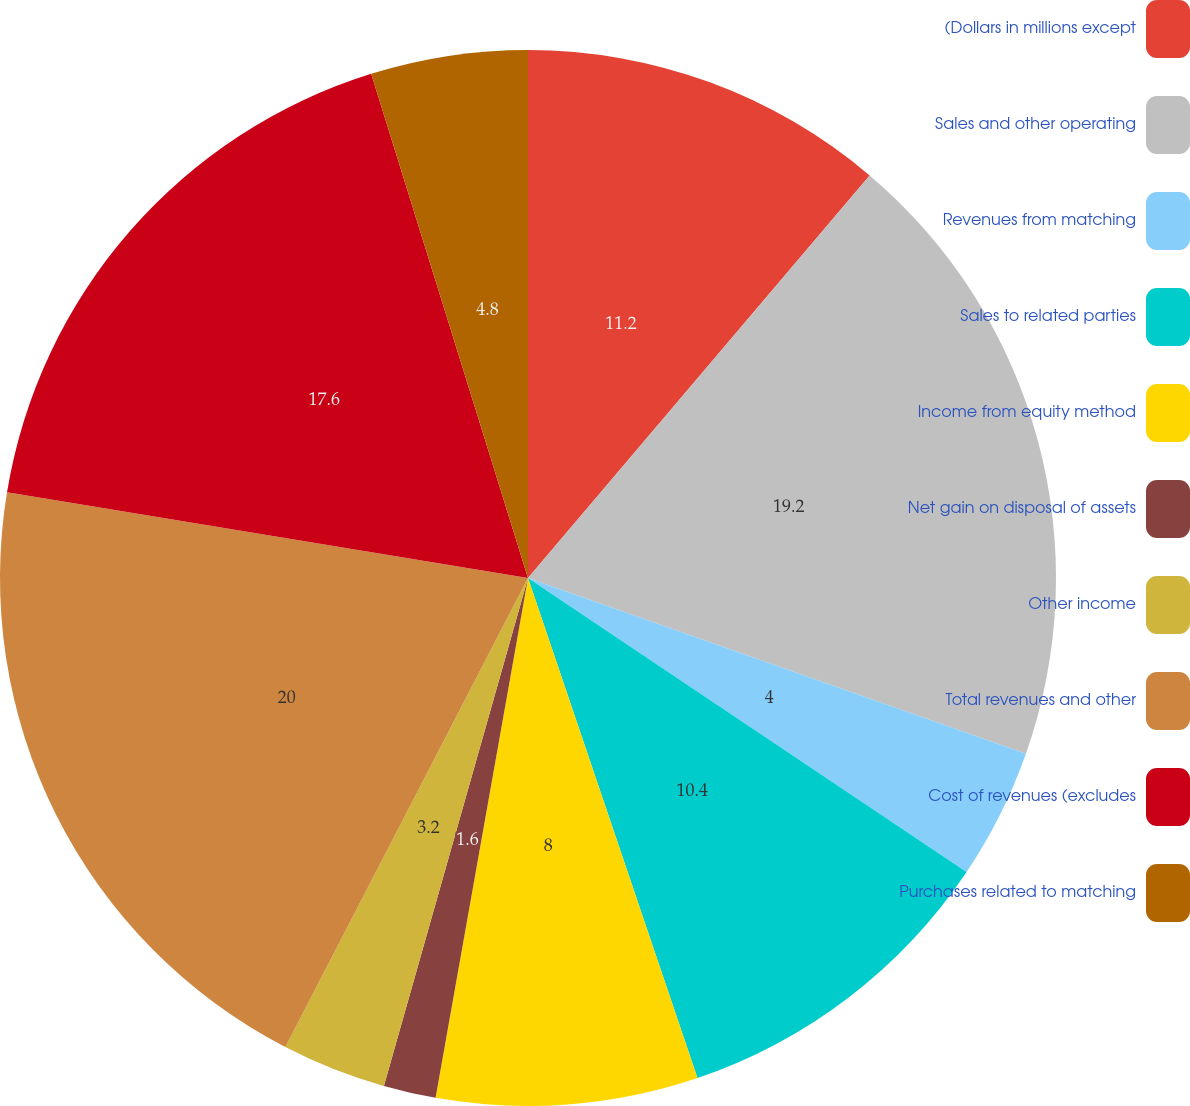Convert chart to OTSL. <chart><loc_0><loc_0><loc_500><loc_500><pie_chart><fcel>(Dollars in millions except<fcel>Sales and other operating<fcel>Revenues from matching<fcel>Sales to related parties<fcel>Income from equity method<fcel>Net gain on disposal of assets<fcel>Other income<fcel>Total revenues and other<fcel>Cost of revenues (excludes<fcel>Purchases related to matching<nl><fcel>11.2%<fcel>19.2%<fcel>4.0%<fcel>10.4%<fcel>8.0%<fcel>1.6%<fcel>3.2%<fcel>20.0%<fcel>17.6%<fcel>4.8%<nl></chart> 